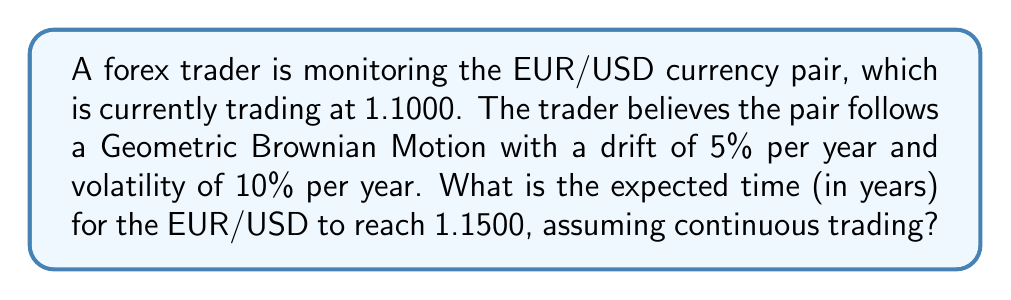What is the answer to this math problem? To solve this problem, we'll use the concept of first passage time for a Geometric Brownian Motion (GBM). The formula for the expected first passage time is:

$$E[T] = \frac{\ln(S_T/S_0) - (\mu - \frac{\sigma^2}{2})T}{\mu - \frac{\sigma^2}{2}}$$

Where:
- $E[T]$ is the expected time
- $S_T$ is the target price
- $S_0$ is the initial price
- $\mu$ is the drift (annualized)
- $\sigma$ is the volatility (annualized)
- $T$ is the time horizon (which we're solving for)

Given:
- $S_0 = 1.1000$
- $S_T = 1.1500$
- $\mu = 5\% = 0.05$
- $\sigma = 10\% = 0.1$

Step 1: Calculate $\mu - \frac{\sigma^2}{2}$
$$0.05 - \frac{0.1^2}{2} = 0.05 - 0.005 = 0.045$$

Step 2: Substitute the values into the equation:
$$E[T] = \frac{\ln(1.1500/1.1000) - (0.045)T}{0.045}$$

Step 3: Simplify:
$$E[T] = \frac{\ln(1.0455) - 0.045T}{0.045}$$

Step 4: Solve for $T$:
$$0.045E[T] = \ln(1.0455) - 0.045T$$
$$0.045E[T] + 0.045T = \ln(1.0455)$$
$$T(0.045 + 0.045) = \ln(1.0455)$$
$$0.09T = 0.0444$$
$$T = \frac{0.0444}{0.09} = 0.4933$$

Therefore, the expected time for the EUR/USD to reach 1.1500 is approximately 0.4933 years.
Answer: 0.4933 years 